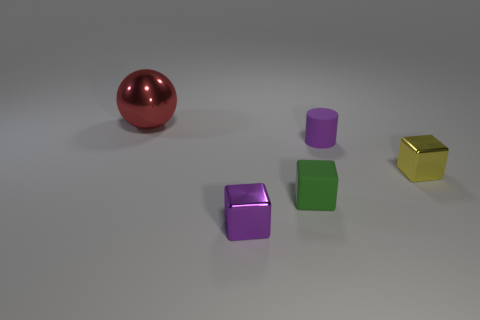Is there any other thing that is the same shape as the big metal thing?
Offer a terse response. No. Is the number of yellow cubes that are to the left of the tiny purple shiny thing less than the number of small purple objects?
Offer a very short reply. Yes. Does the tiny block to the left of the green matte object have the same color as the cylinder?
Give a very brief answer. Yes. What number of matte objects are either brown cubes or purple cylinders?
Make the answer very short. 1. Are there any other things that are the same size as the sphere?
Offer a very short reply. No. What color is the object that is the same material as the purple cylinder?
Provide a succinct answer. Green. How many cubes are green things or yellow metallic things?
Ensure brevity in your answer.  2. How many objects are big green metallic cylinders or shiny blocks that are in front of the yellow block?
Offer a very short reply. 1. Are any purple things visible?
Keep it short and to the point. Yes. What number of other rubber cylinders have the same color as the cylinder?
Your answer should be compact. 0. 